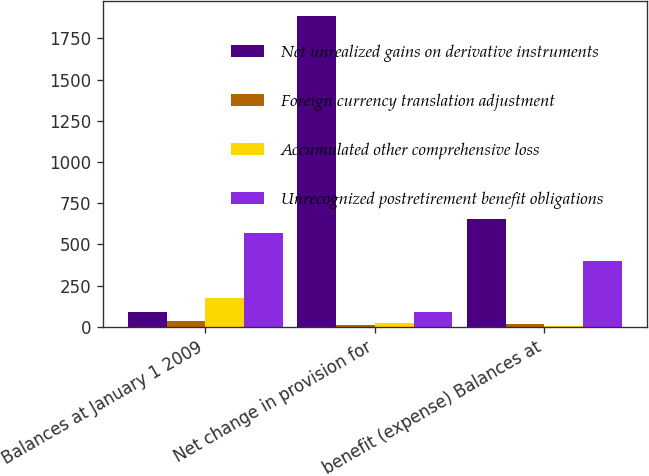Convert chart. <chart><loc_0><loc_0><loc_500><loc_500><stacked_bar_chart><ecel><fcel>Balances at January 1 2009<fcel>Net change in provision for<fcel>benefit (expense) Balances at<nl><fcel>Net unrealized gains on derivative instruments<fcel>92.2<fcel>1884.3<fcel>654.8<nl><fcel>Foreign currency translation adjustment<fcel>37.2<fcel>10.3<fcel>14.3<nl><fcel>Accumulated other comprehensive loss<fcel>173.5<fcel>23.6<fcel>5.3<nl><fcel>Unrecognized postretirement benefit obligations<fcel>567.3<fcel>92.2<fcel>396.2<nl></chart> 